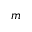<formula> <loc_0><loc_0><loc_500><loc_500>m</formula> 